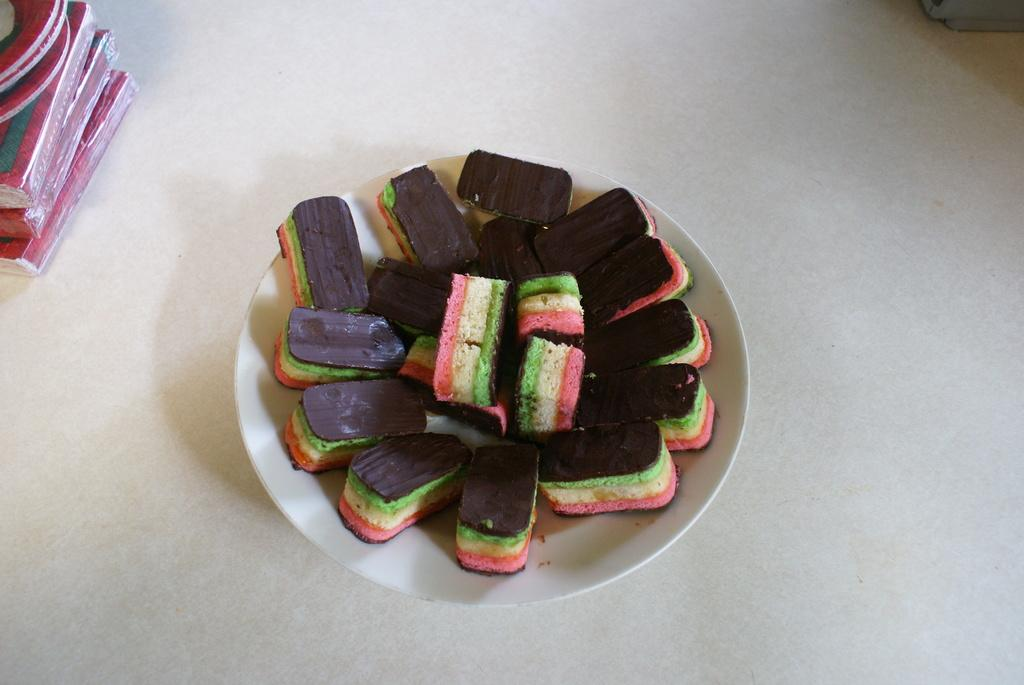What is the color of the surface in the image? The surface in the image is white. What objects are placed on the white surface? There are books and a white plate on the white surface. What is on the white plate? There is food on the white plate. What decision does the goose make in the image? There is no goose present in the image, so no decision can be made by a goose. 